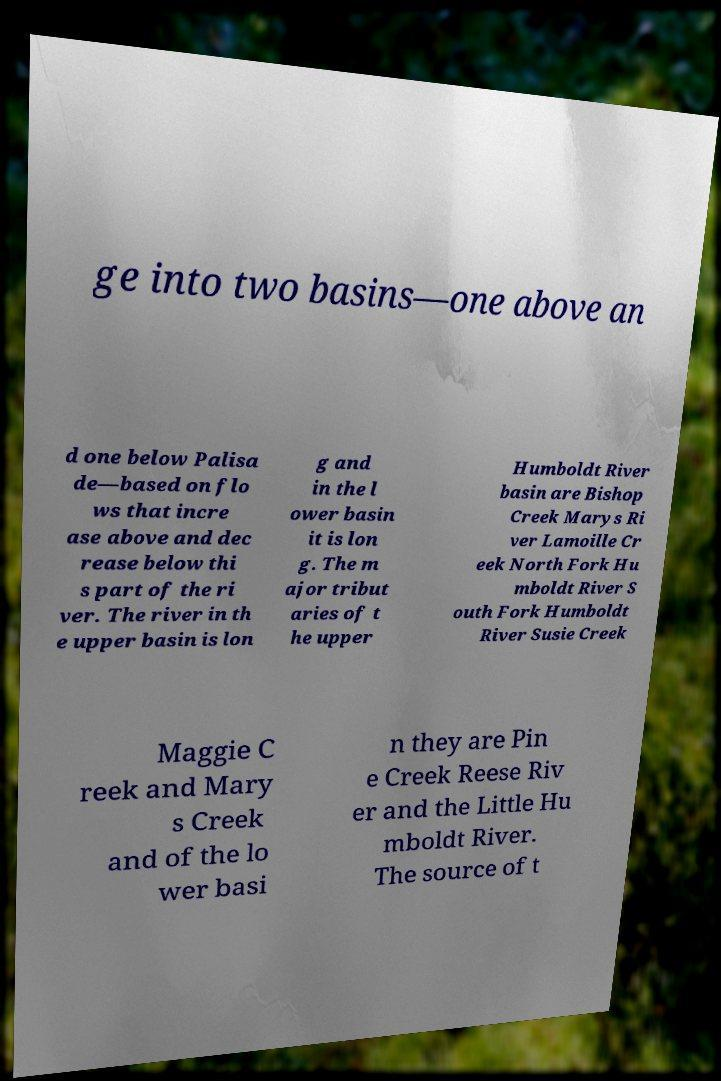Could you assist in decoding the text presented in this image and type it out clearly? ge into two basins—one above an d one below Palisa de—based on flo ws that incre ase above and dec rease below thi s part of the ri ver. The river in th e upper basin is lon g and in the l ower basin it is lon g. The m ajor tribut aries of t he upper Humboldt River basin are Bishop Creek Marys Ri ver Lamoille Cr eek North Fork Hu mboldt River S outh Fork Humboldt River Susie Creek Maggie C reek and Mary s Creek and of the lo wer basi n they are Pin e Creek Reese Riv er and the Little Hu mboldt River. The source of t 